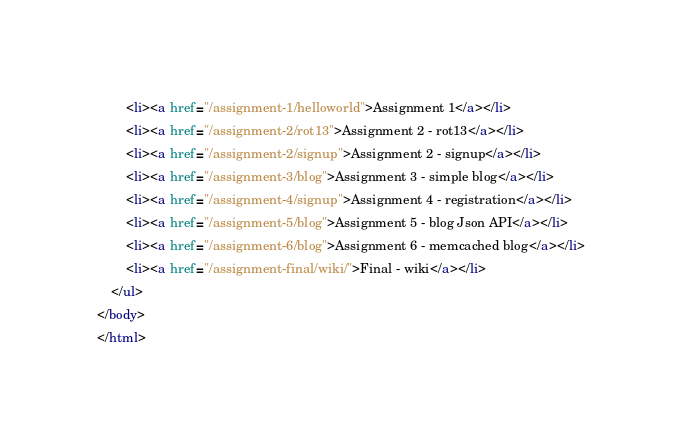Convert code to text. <code><loc_0><loc_0><loc_500><loc_500><_HTML_>		<li><a href="/assignment-1/helloworld">Assignment 1</a></li>
		<li><a href="/assignment-2/rot13">Assignment 2 - rot13</a></li>
        <li><a href="/assignment-2/signup">Assignment 2 - signup</a></li>
        <li><a href="/assignment-3/blog">Assignment 3 - simple blog</a></li>
        <li><a href="/assignment-4/signup">Assignment 4 - registration</a></li>
        <li><a href="/assignment-5/blog">Assignment 5 - blog Json API</a></li>        
        <li><a href="/assignment-6/blog">Assignment 6 - memcached blog</a></li>
        <li><a href="/assignment-final/wiki/">Final - wiki</a></li>
	</ul>
</body>
</html></code> 